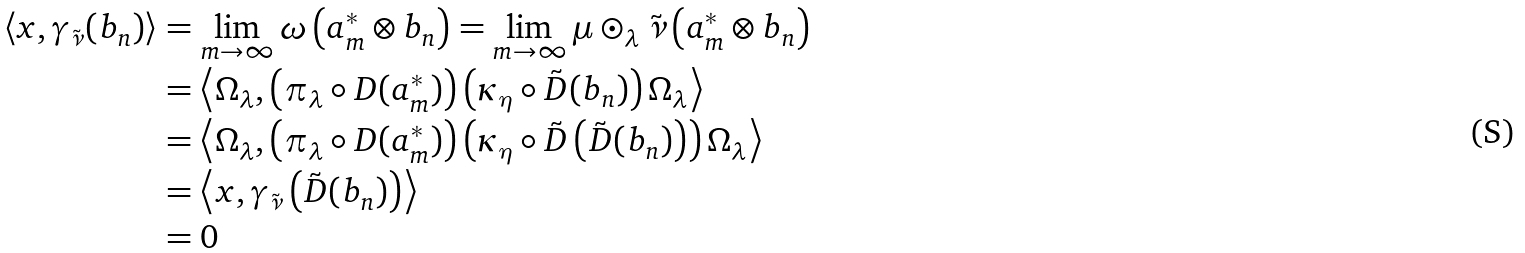<formula> <loc_0><loc_0><loc_500><loc_500>\left \langle x , \gamma _ { \tilde { \nu } } ( b _ { n } ) \right \rangle & = \lim _ { m \rightarrow \infty } \omega \left ( a _ { m } ^ { \ast } \otimes b _ { n } \right ) = \lim _ { m \rightarrow \infty } \mu \odot _ { \lambda } \tilde { \nu } \left ( a _ { m } ^ { \ast } \otimes b _ { n } \right ) \\ & = \left \langle \Omega _ { \lambda } , \left ( \pi _ { \lambda } \circ D ( a _ { m } ^ { \ast } ) \right ) \left ( \kappa _ { \eta } \circ \tilde { D } ( b _ { n } ) \right ) \Omega _ { \lambda } \right \rangle \\ & = \left \langle \Omega _ { \lambda } , \left ( \pi _ { \lambda } \circ D ( a _ { m } ^ { \ast } ) \right ) \left ( \kappa _ { \eta } \circ \tilde { D } \left ( \tilde { D } ( b _ { n } ) \right ) \right ) \Omega _ { \lambda } \right \rangle \\ & = \left \langle x , \gamma _ { \tilde { \nu } } \left ( \tilde { D } ( b _ { n } ) \right ) \right \rangle \\ & = 0</formula> 